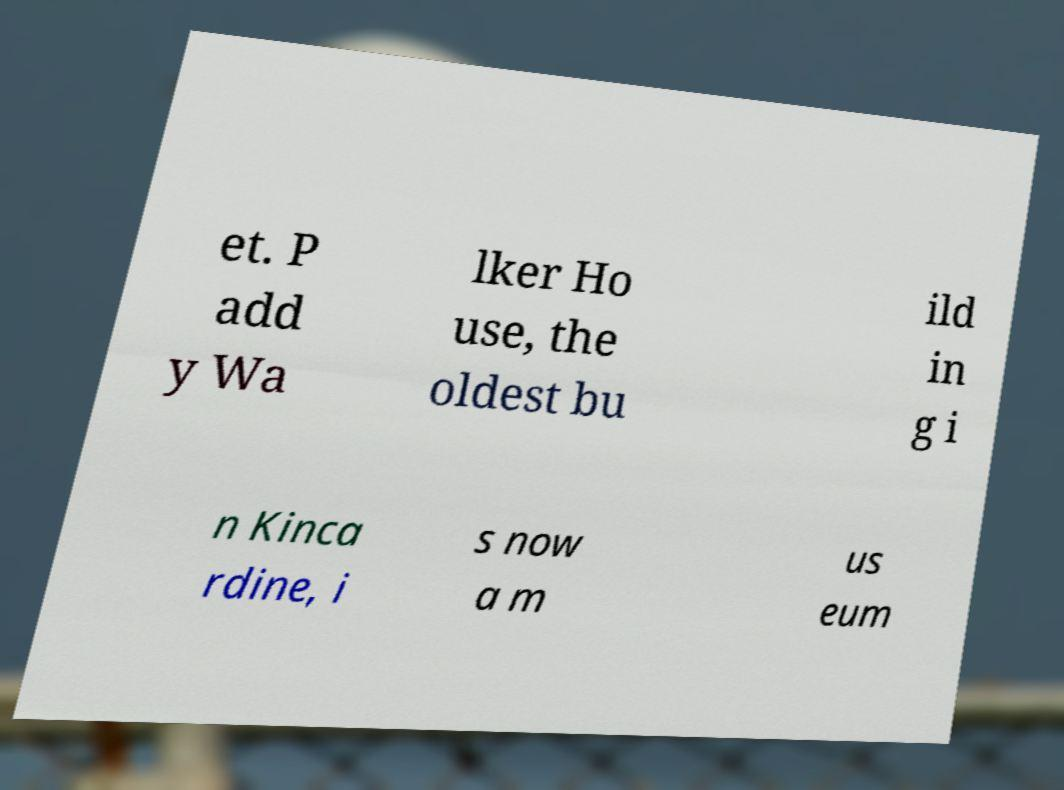Please identify and transcribe the text found in this image. et. P add y Wa lker Ho use, the oldest bu ild in g i n Kinca rdine, i s now a m us eum 